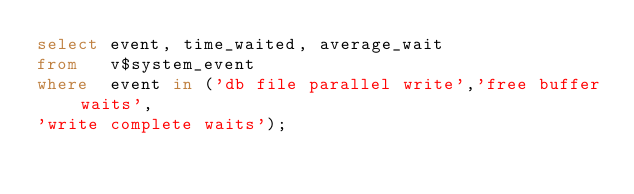<code> <loc_0><loc_0><loc_500><loc_500><_SQL_>select event, time_waited, average_wait 
from   v$system_event 
where  event in ('db file parallel write','free buffer waits', 
'write complete waits'); 
</code> 